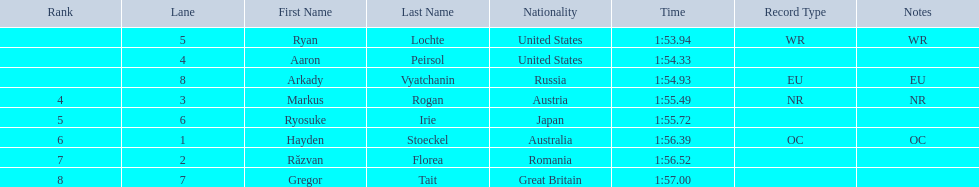What is the name of the contestant in lane 6? Ryosuke Irie. How long did it take that player to complete the race? 1:55.72. 